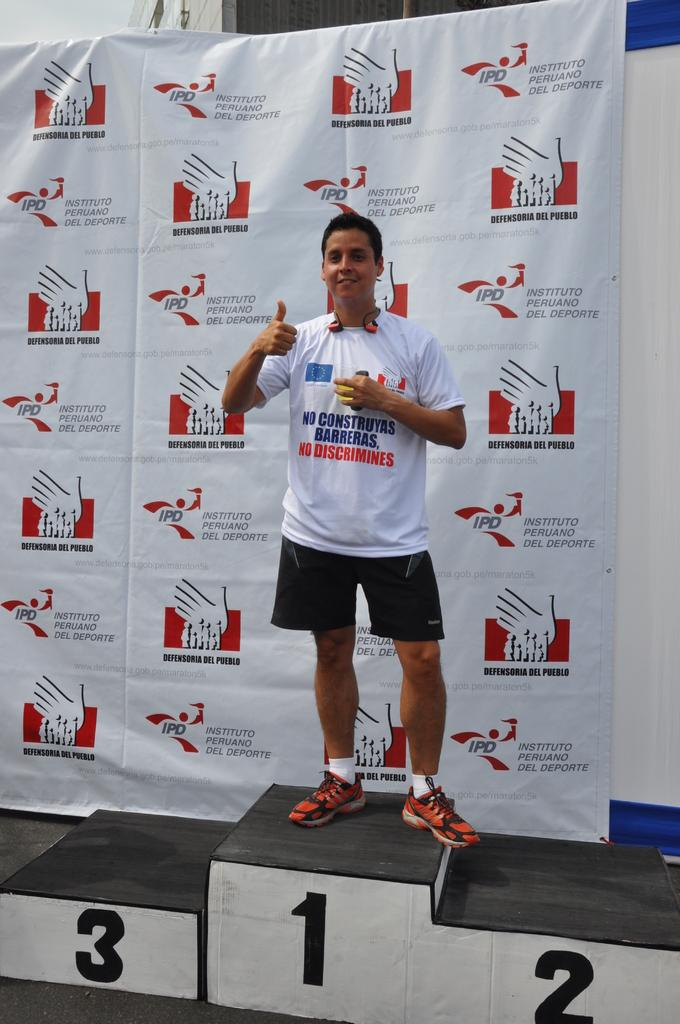What is the main subject of the image? There is a man standing in the image. What can be seen in the background of the image? There is a banner with logos and text, as well as a wall visible in the background. What is the man wearing in the image? The man's t-shirt has text on it. Can you see any stone structures in the image? There are no stone structures present in the image. Are there any fairies visible in the image? There are no fairies present in the image. 